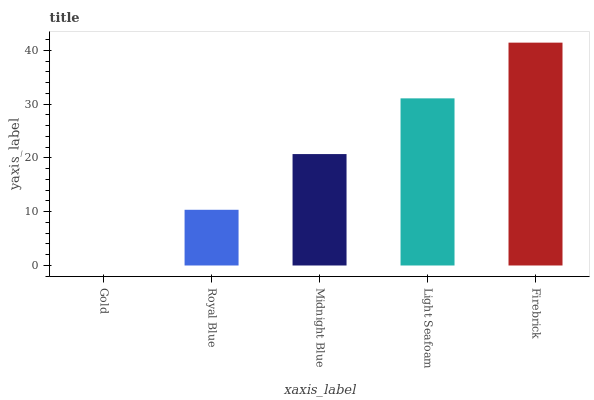Is Gold the minimum?
Answer yes or no. Yes. Is Firebrick the maximum?
Answer yes or no. Yes. Is Royal Blue the minimum?
Answer yes or no. No. Is Royal Blue the maximum?
Answer yes or no. No. Is Royal Blue greater than Gold?
Answer yes or no. Yes. Is Gold less than Royal Blue?
Answer yes or no. Yes. Is Gold greater than Royal Blue?
Answer yes or no. No. Is Royal Blue less than Gold?
Answer yes or no. No. Is Midnight Blue the high median?
Answer yes or no. Yes. Is Midnight Blue the low median?
Answer yes or no. Yes. Is Firebrick the high median?
Answer yes or no. No. Is Gold the low median?
Answer yes or no. No. 